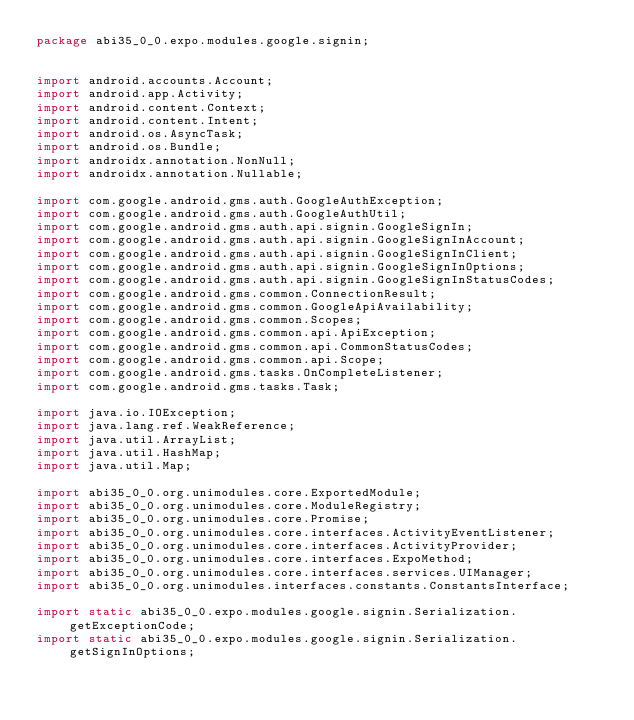<code> <loc_0><loc_0><loc_500><loc_500><_Java_>package abi35_0_0.expo.modules.google.signin;


import android.accounts.Account;
import android.app.Activity;
import android.content.Context;
import android.content.Intent;
import android.os.AsyncTask;
import android.os.Bundle;
import androidx.annotation.NonNull;
import androidx.annotation.Nullable;

import com.google.android.gms.auth.GoogleAuthException;
import com.google.android.gms.auth.GoogleAuthUtil;
import com.google.android.gms.auth.api.signin.GoogleSignIn;
import com.google.android.gms.auth.api.signin.GoogleSignInAccount;
import com.google.android.gms.auth.api.signin.GoogleSignInClient;
import com.google.android.gms.auth.api.signin.GoogleSignInOptions;
import com.google.android.gms.auth.api.signin.GoogleSignInStatusCodes;
import com.google.android.gms.common.ConnectionResult;
import com.google.android.gms.common.GoogleApiAvailability;
import com.google.android.gms.common.Scopes;
import com.google.android.gms.common.api.ApiException;
import com.google.android.gms.common.api.CommonStatusCodes;
import com.google.android.gms.common.api.Scope;
import com.google.android.gms.tasks.OnCompleteListener;
import com.google.android.gms.tasks.Task;

import java.io.IOException;
import java.lang.ref.WeakReference;
import java.util.ArrayList;
import java.util.HashMap;
import java.util.Map;

import abi35_0_0.org.unimodules.core.ExportedModule;
import abi35_0_0.org.unimodules.core.ModuleRegistry;
import abi35_0_0.org.unimodules.core.Promise;
import abi35_0_0.org.unimodules.core.interfaces.ActivityEventListener;
import abi35_0_0.org.unimodules.core.interfaces.ActivityProvider;
import abi35_0_0.org.unimodules.core.interfaces.ExpoMethod;
import abi35_0_0.org.unimodules.core.interfaces.services.UIManager;
import abi35_0_0.org.unimodules.interfaces.constants.ConstantsInterface;

import static abi35_0_0.expo.modules.google.signin.Serialization.getExceptionCode;
import static abi35_0_0.expo.modules.google.signin.Serialization.getSignInOptions;</code> 